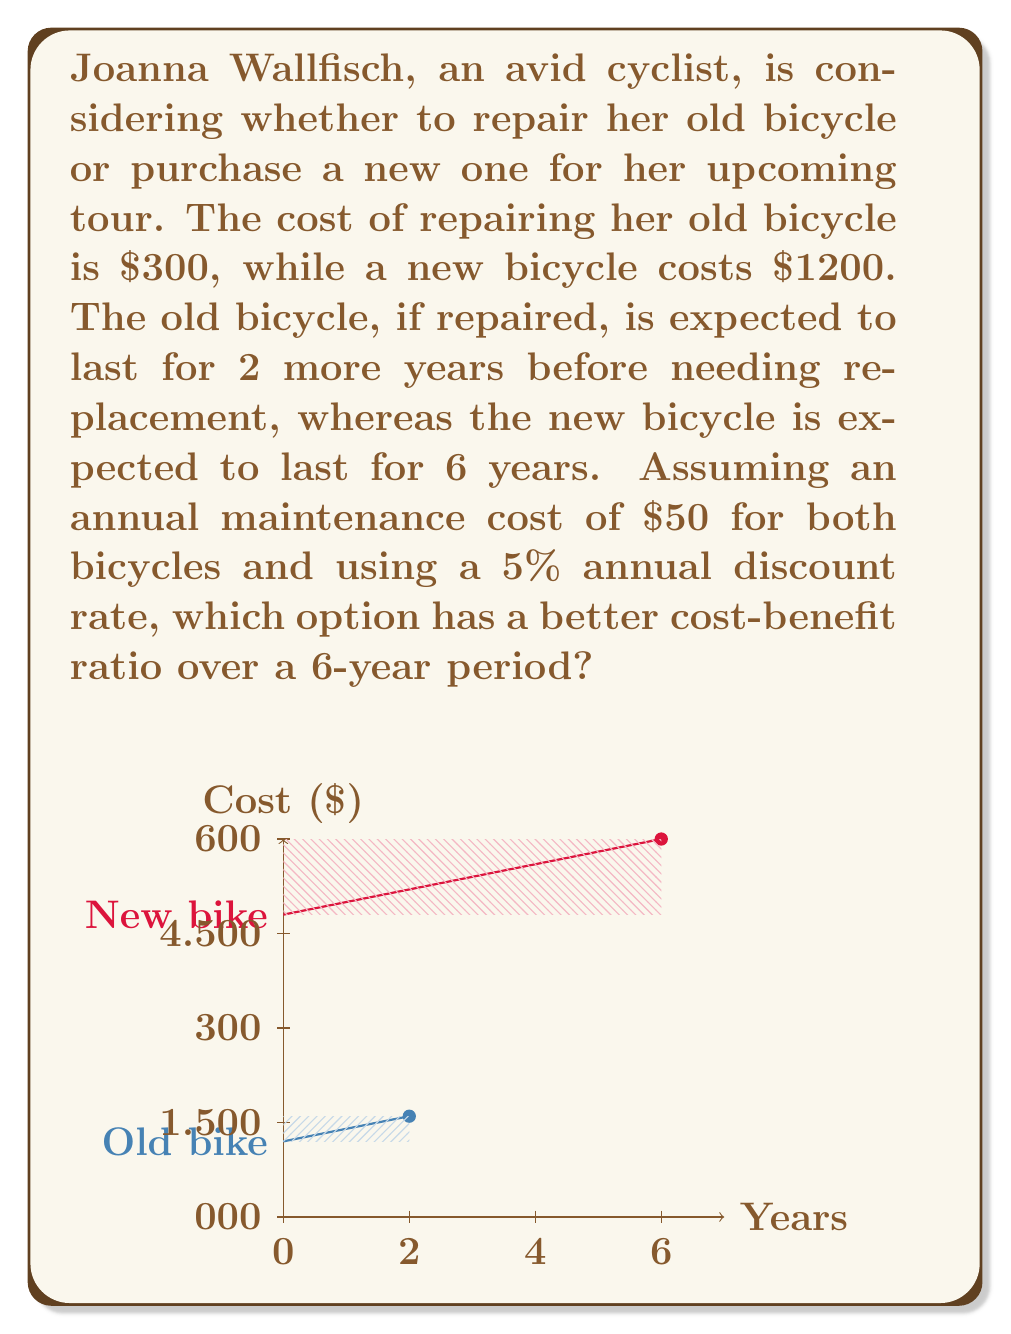Solve this math problem. Let's approach this step-by-step:

1) First, we need to calculate the present value of costs for both options over 6 years.

2) For the old bicycle:
   - Initial repair cost: $300
   - Annual maintenance: $50 for 2 years
   - New bicycle purchase after 2 years: $1200
   - Annual maintenance for new bicycle: $50 for 4 years

3) For the new bicycle:
   - Initial purchase: $1200
   - Annual maintenance: $50 for 6 years

4) We'll use the present value formula: $PV = \frac{FV}{(1+r)^n}$, where r is the discount rate and n is the number of years.

5) Old bicycle cost:
   $PV_{old} = 300 + \frac{50}{1.05^1} + \frac{50}{1.05^2} + \frac{1200}{1.05^2} + \frac{50}{1.05^3} + \frac{50}{1.05^4} + \frac{50}{1.05^5} + \frac{50}{1.05^6}$

6) New bicycle cost:
   $PV_{new} = 1200 + \frac{50}{1.05^1} + \frac{50}{1.05^2} + \frac{50}{1.05^3} + \frac{50}{1.05^4} + \frac{50}{1.05^5} + \frac{50}{1.05^6}$

7) Calculating these values:
   $PV_{old} \approx 1635.87$
   $PV_{new} \approx 1432.95$

8) To calculate the cost-benefit ratio, we need to consider the benefit. In this case, we can assume the benefit is the same for both options (6 years of cycling). So, we can use the inverse of the cost as our ratio.

9) Cost-benefit ratio:
   Old bicycle: $1 / 1635.87 \approx 0.000611$
   New bicycle: $1 / 1432.95 \approx 0.000698$

10) The higher ratio indicates a better cost-benefit, so the new bicycle is the better option.
Answer: New bicycle (ratio ≈ 0.000698 vs 0.000611) 